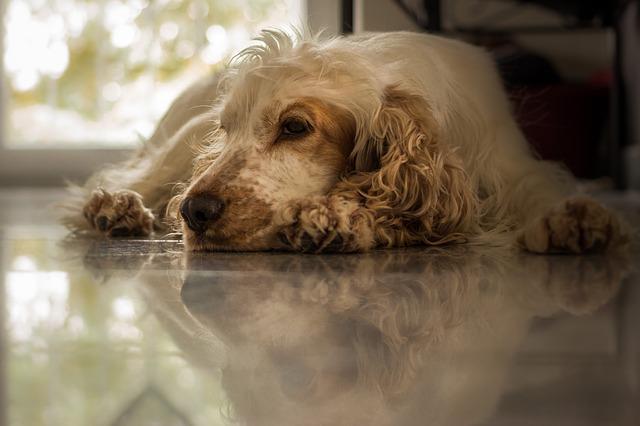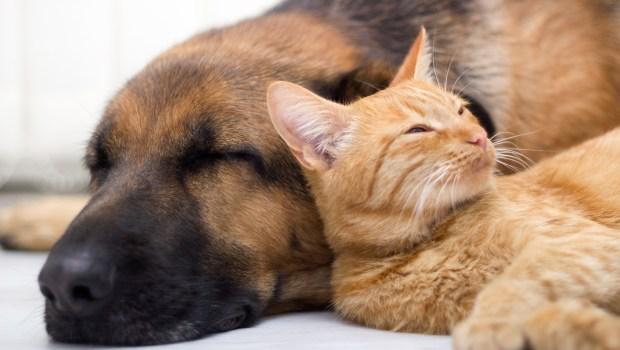The first image is the image on the left, the second image is the image on the right. Evaluate the accuracy of this statement regarding the images: "The dog in the image on the right is sitting.". Is it true? Answer yes or no. No. 